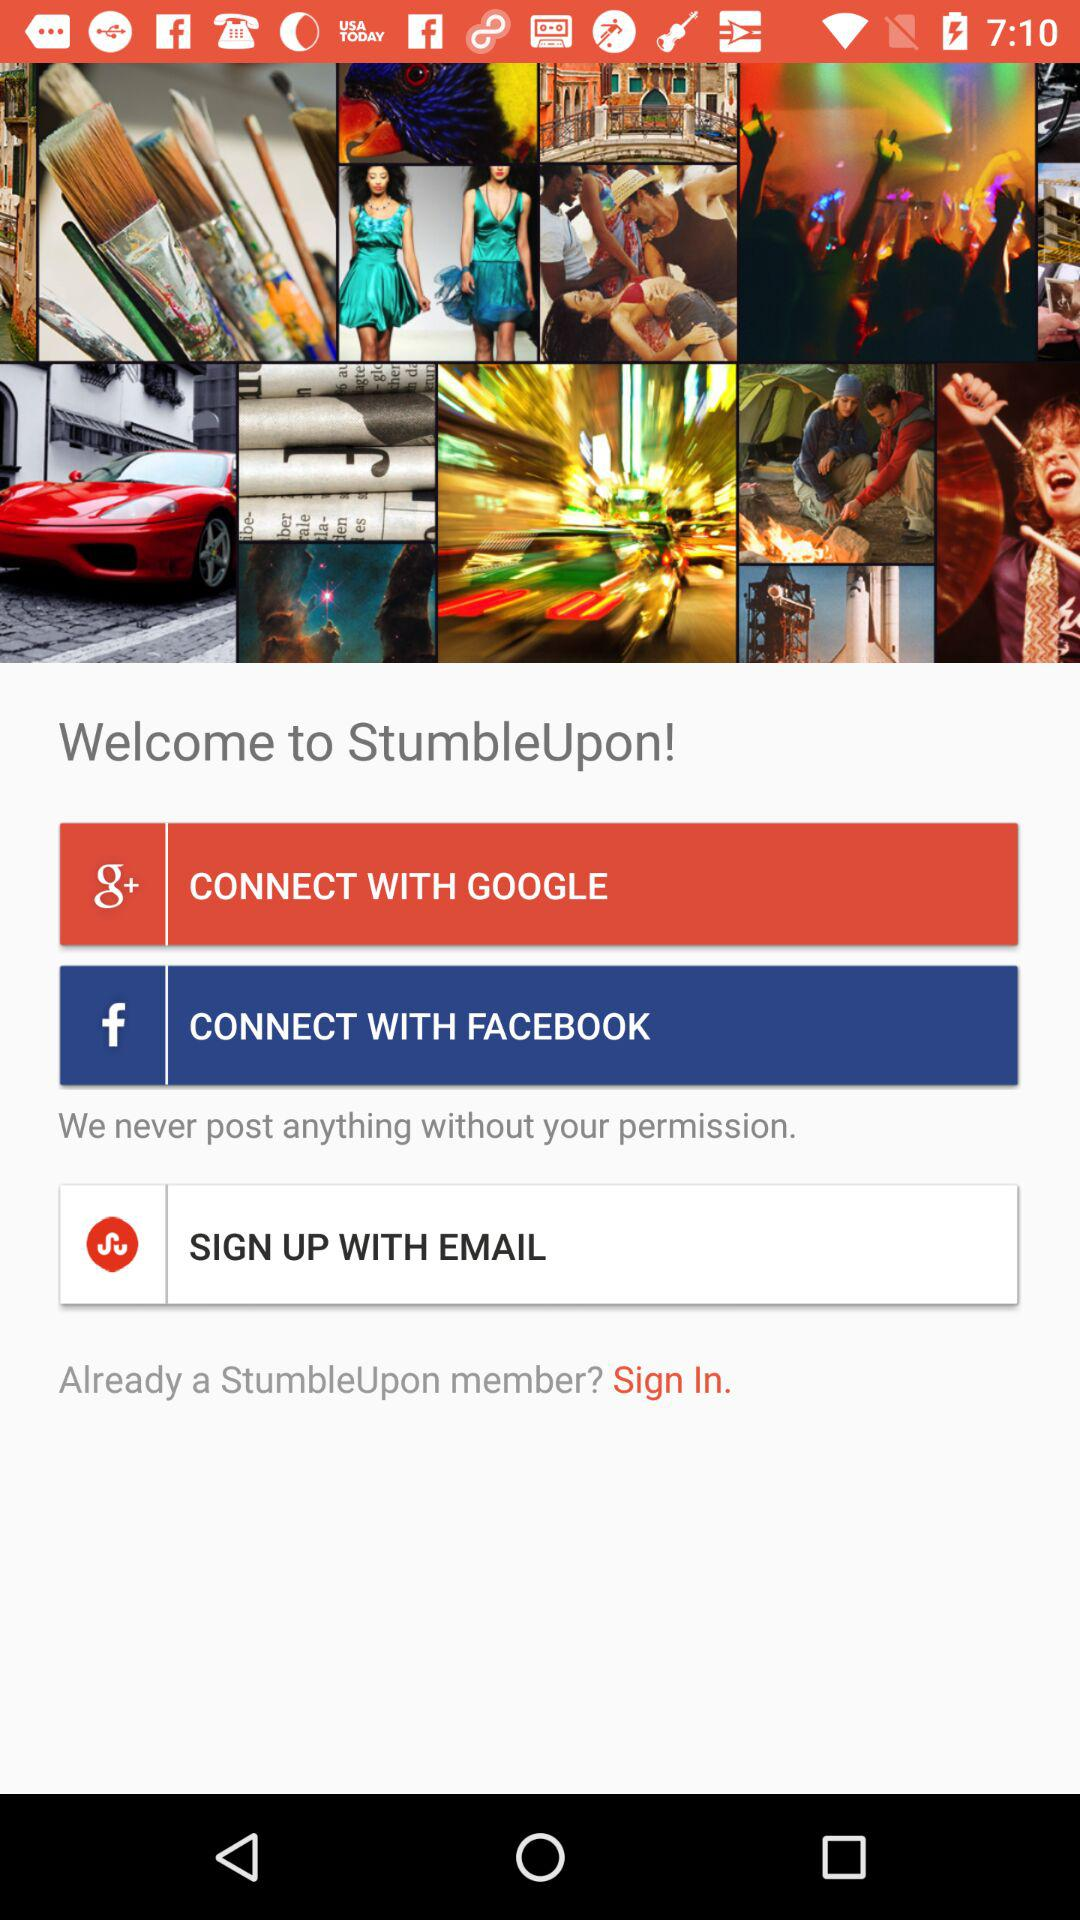What options are available to sign up? The available options are "GOOGLE", "FACEBOOK" and "EMAIL". 